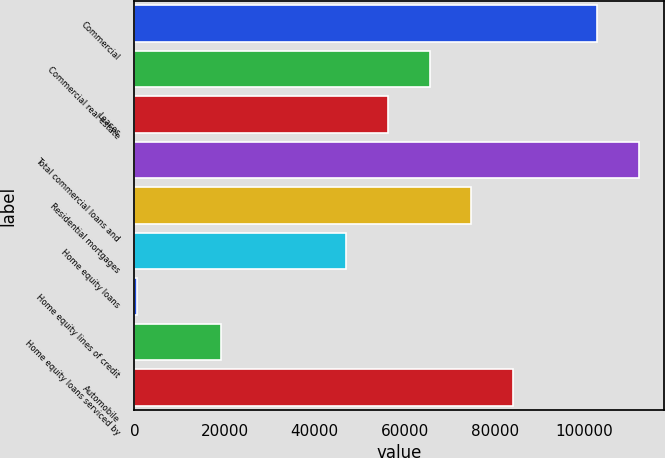<chart> <loc_0><loc_0><loc_500><loc_500><bar_chart><fcel>Commercial<fcel>Commercial real estate<fcel>Leases<fcel>Total commercial loans and<fcel>Residential mortgages<fcel>Home equity loans<fcel>Home equity lines of credit<fcel>Home equity loans serviced by<fcel>Automobile<nl><fcel>102696<fcel>65552<fcel>56266<fcel>111982<fcel>74838<fcel>46980<fcel>550<fcel>19122<fcel>84124<nl></chart> 